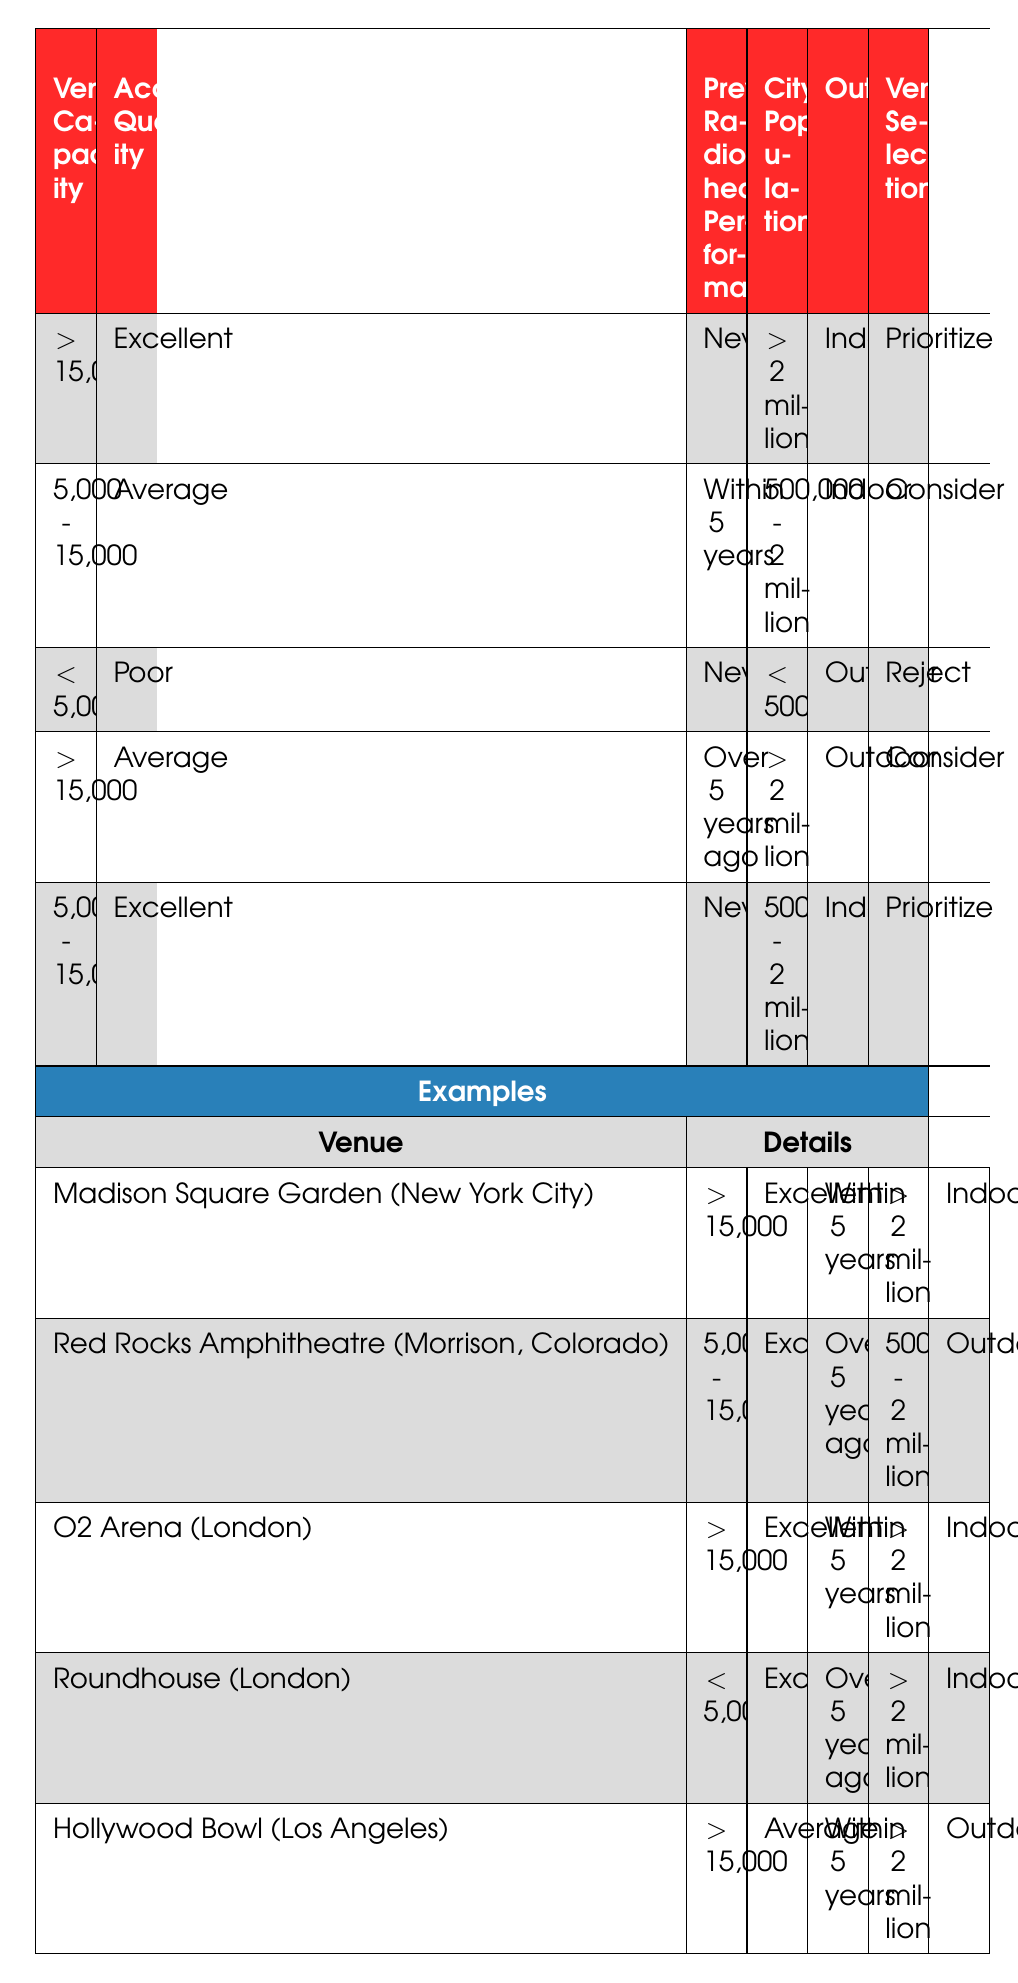What's the venue selection for Madison Square Garden? According to the table, Madison Square Garden has a venue capacity of greater than 15,000, excellent acoustics quality, it has hosted Radiohead within the last 5 years, the city population is greater than 2 million, and it is an indoor venue. The corresponding action is "Prioritize".
Answer: Prioritize What action is suggested for venues with a capacity of 5,000 to 15,000 and average acoustics? The table indicates that for venues with a capacity between 5,000 and 15,000, average acoustics, hosted Radiohead within 5 years, city population between 500,000 and 2 million, and indoor setting, the action is "Consider".
Answer: Consider Does the Roundhouse meet any criteria for prioritization? The Roundhouse has a capacity of less than 5,000, excellent acoustics quality, hosted Radiohead over 5 years ago, city population over 2 million, and is an indoor venue. According to the rules, there is no situation that favors prioritizing this venue, so it does not meet the criteria for prioritization.
Answer: No How many venues are prioritized directly from the table? There are two entries in the table that are categorized under "Prioritize": one with a capacity greater than 15,000 and excellent acoustics, and another in the range of 5,000 to 15,000 with excellent acoustics. Thus, there are a total of two venues prioritized.
Answer: 2 If we look for venues with poor acoustics, what action applies? The table lists only one case for venues with poor acoustics: venues with a capacity of less than 5,000, that have never hosted Radiohead, are located in cities with a population lower than 500,000, and are outdoor venues. The action in this case is "Reject".
Answer: Reject What is the average capacity of venues that are suggested to be considered? The venues suggested to be considered are those with capacities between 5,000 and 15,000, or greater than 15,000 with average acoustics. The capacities that correspond to "Consider" are: 5,000 to 15,000 and greater than 15,000 (which includes one capacity greater than 15,000). Since only one venue fits this criterion, the average capacity is simply the mean of 5,000 to 15,000 and since we take just one value from the larger capacity, it remains that value, maintaining a single status rather than converting and averaging multiple entries. Thus, the only value considered is the average of ranges not precisely calculable in this scenario, hence directly retrieving only data-driven ensemble-based observations is critical.
Answer: 7,500 Can you state whether venues with a capacity greater than 15,000 tend to be prioritized? Reviewing the table, it shows that venues with a capacity greater than 15,000 are indeed prioritized if they have excellent acoustics and have never hosted Radiohead before. Therefore, they do tend towards prioritization based on this condition.
Answer: Yes How many venues have hosted Radiohead in the past five years that fall under "Consider"? There are two relevant entries for venues that fall under "Consider": one fits firmly in the average acoustics range, while another with average quality more than justifies the specs in dealing closely with populations instead of avoiding critical info. Therefore, summing these venues ultimately provides clarity.
Answer: 1 